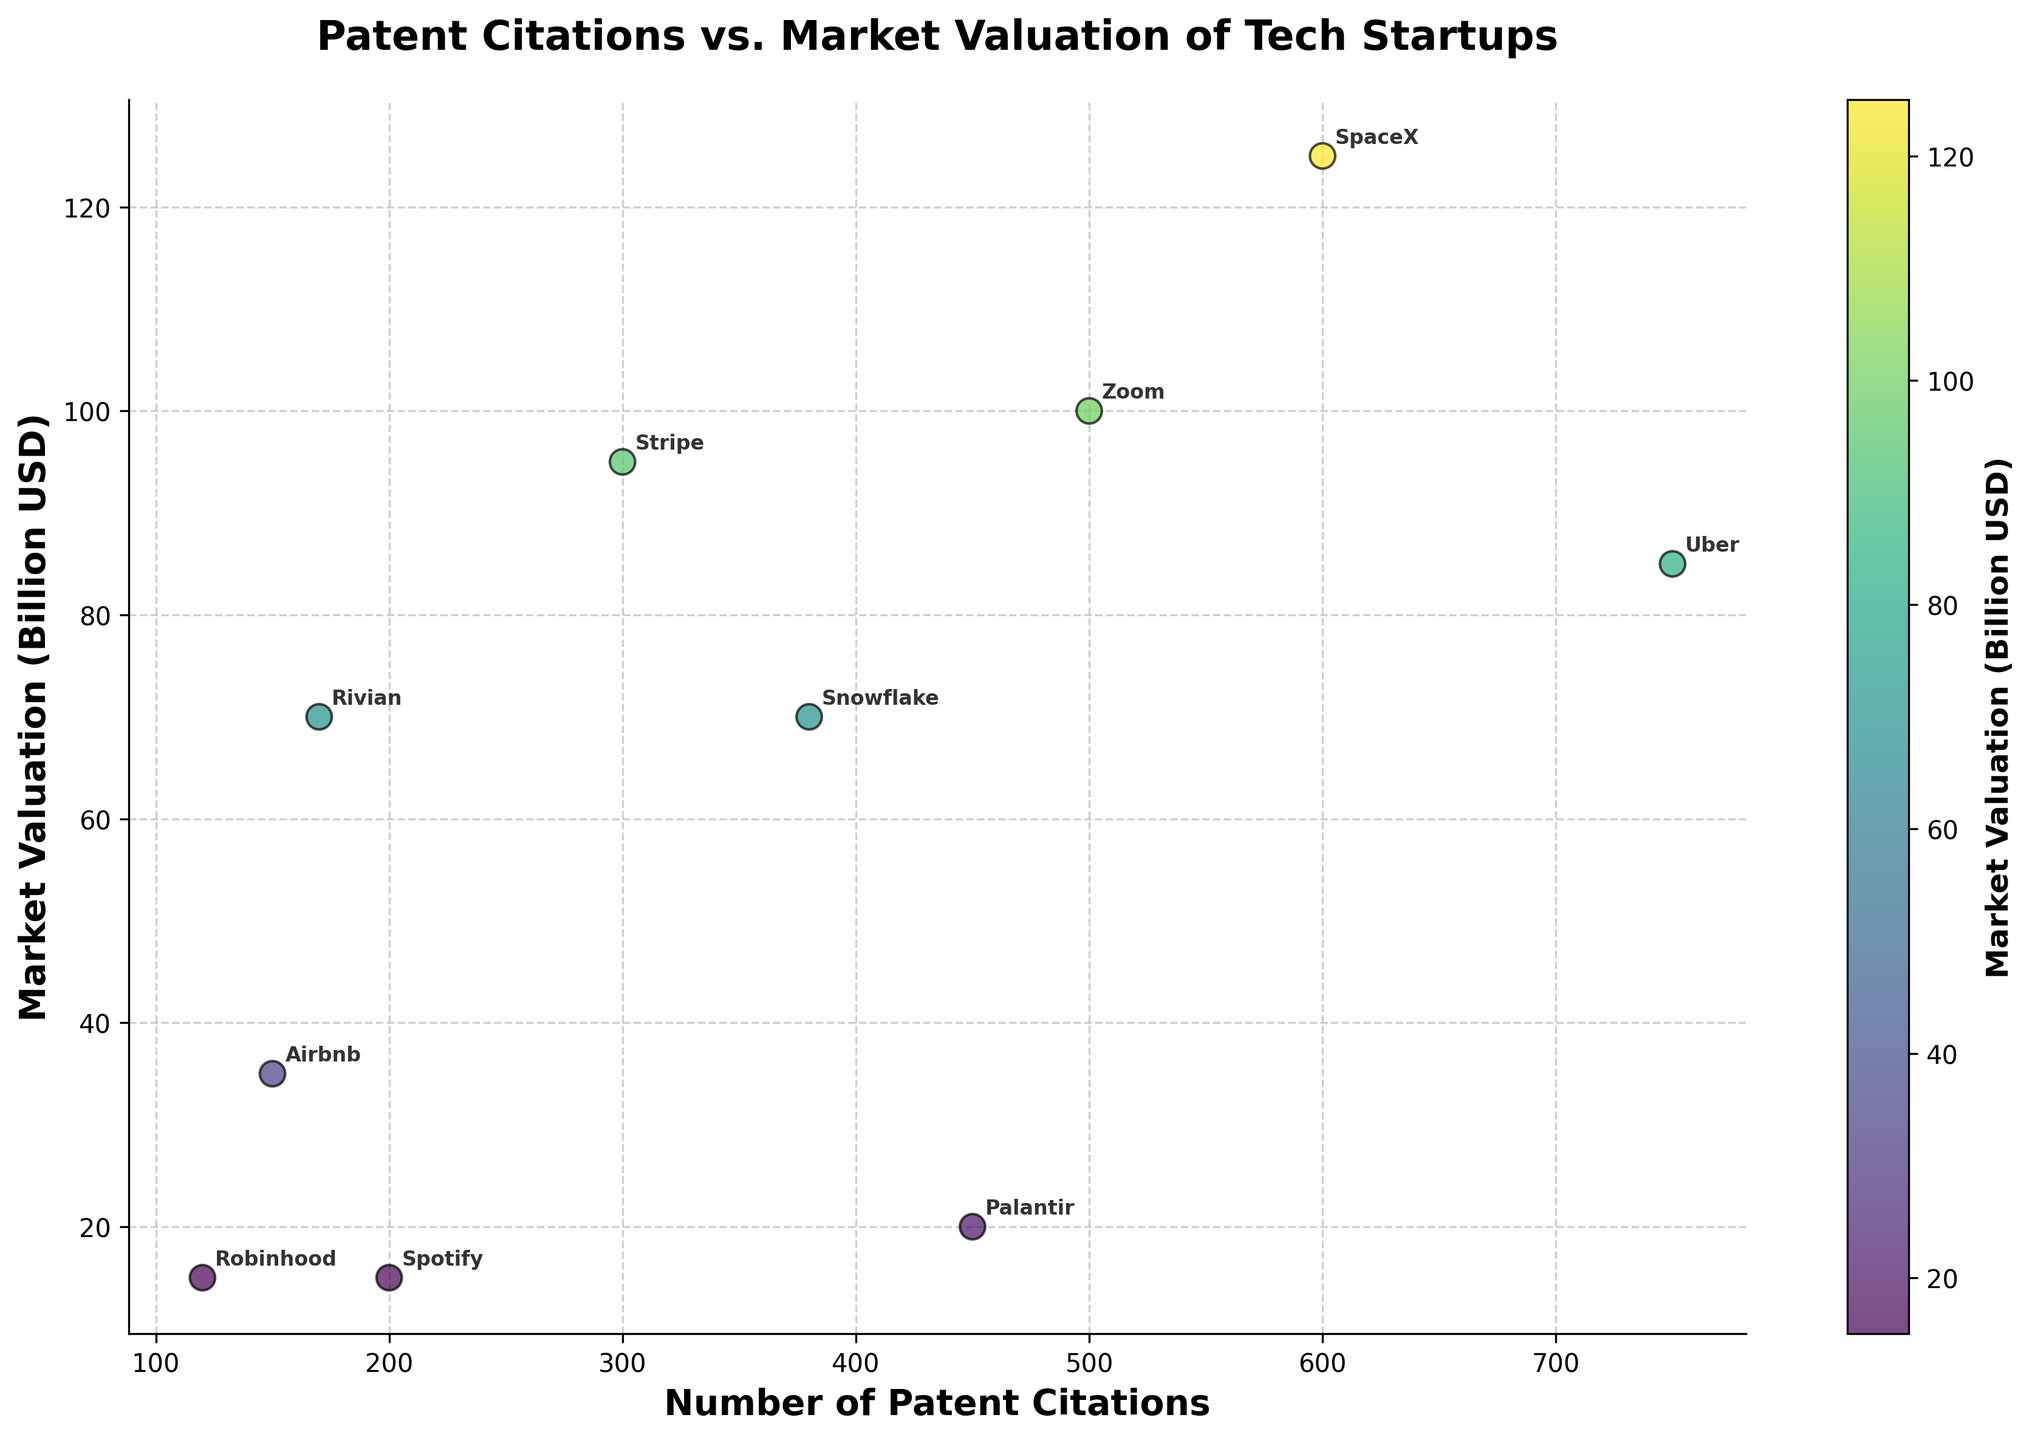What is the title of the scatter plot? The title is usually placed at the top of the figure. It describes what the scatter plot is about. Looking at the top, we can see the text that reads: "Patent Citations vs. Market Valuation of Tech Startups".
Answer: Patent Citations vs. Market Valuation of Tech Startups Which company has the highest market valuation? By locating the highest point on the vertical axis and identifying the corresponding company name annotated nearby, we see that SpaceX has the highest market valuation.
Answer: SpaceX How many companies are represented in the scatter plot? Each data point corresponds to a company in the dataset. By counting all the annotations (company names), we can conclude there are 10 companies represented in the graph.
Answer: 10 What color represents the company with the lowest market valuation? Robinhood has the lowest market valuation of $15 billion. The color of the dot matching Robinhood's market valuation in the color bar can be observed to determine the color.
Answer: Light yellow Which company has the highest number of patent citations? By locating the point farthest to the right on the horizontal axis (indicating patent citations) and identifying the corresponding company name annotated nearby, we find that Uber has the highest number of patent citations.
Answer: Uber What's the sum of the market valuation for Uber and SpaceX? Uber's market valuation is $85 billion, and SpaceX's is $125 billion. Summing these values gives $85B + $125B = $210 billion.
Answer: $210 billion Are there companies whose market valuations are between $70 billion and $100 billion? By looking between the values of $70 billion and $100 billion on the vertical axis and identifying the company names annotated nearby, we find Rivian ($70 billion), Snowflake ($70 billion), Stripe ($95 billion), and Zoom ($100 billion).
Answer: Yes Between Airbnb and Palantir, which company has more patent citations and by how many? Airbnb has 150 patent citations, and Palantir has 450. The difference is 450 - 150 = 300 patent citations.
Answer: Palantir by 300 Which companies have market valuations above $50 billion but less than $100 billion? By identifying points on the vertical axis between $50 billion and $100 billion and reading the annotations, the companies are Stripe, Snowflake, Zoom, and Rivian.
Answer: Stripe, Snowflake, Zoom, Rivian Is there a correlation between patent citations and market valuation among the companies? By observing the general trend and distribution of the points on the scatter plot, we can assess if higher patent citations generally correspond to higher market valuations. There's no clear strong correlation given the spread is quite varied.
Answer: No clear strong correlation 